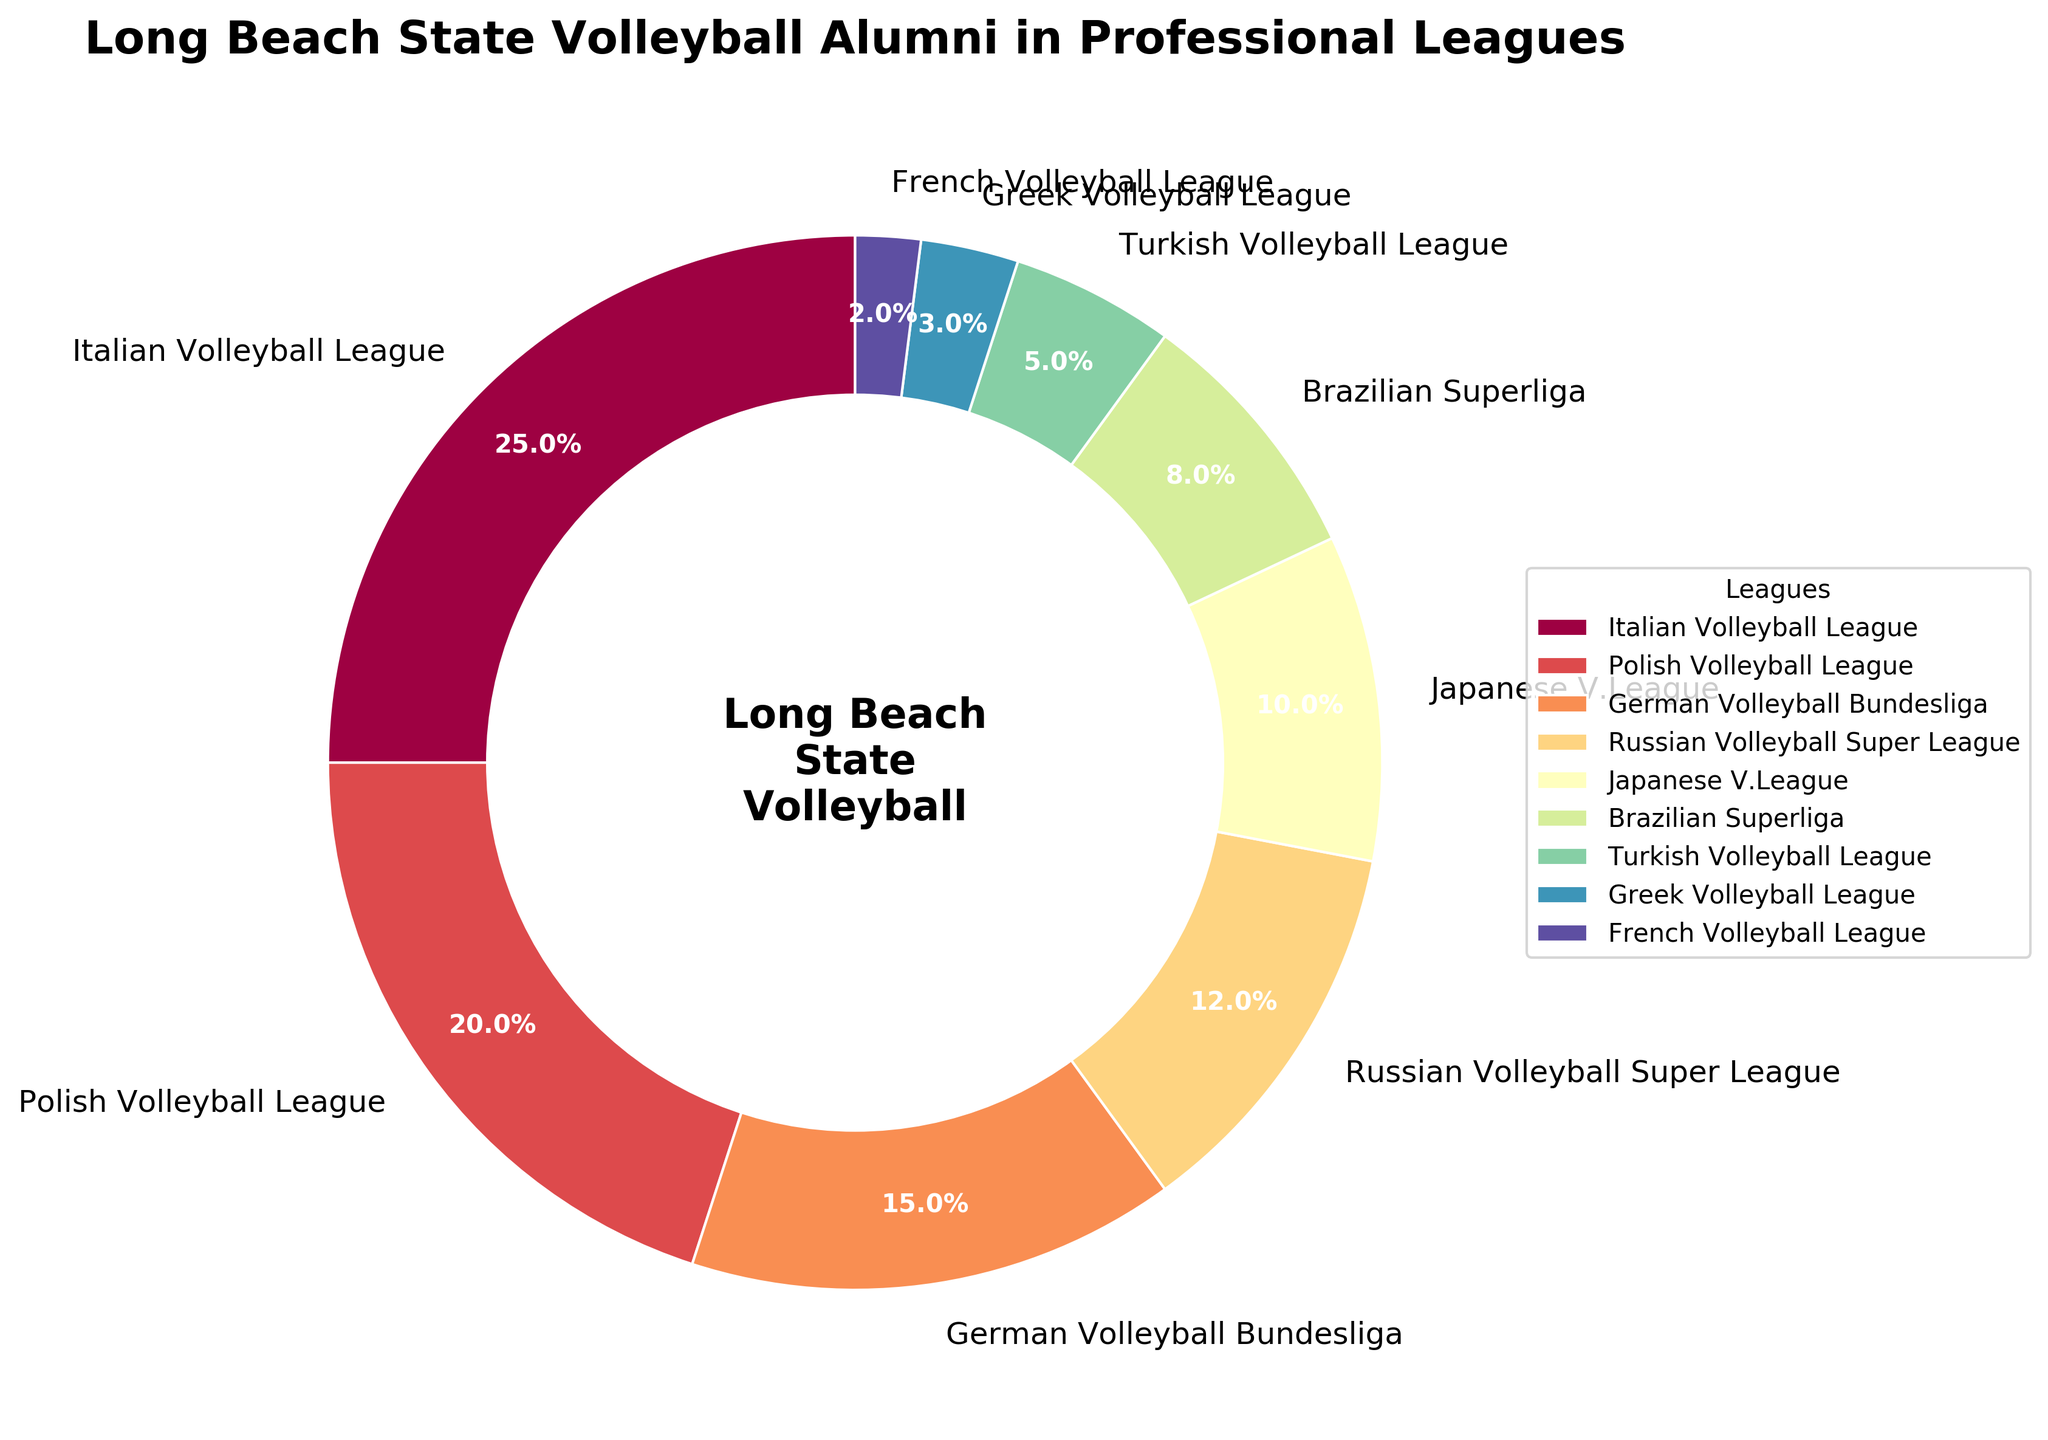What percentage of Long Beach State volleyball alumni are playing in the Italian Volleyball League? The pie chart shows that the Italian Volleyball League slice is labeled with the percentage 25%.
Answer: 25% Which league has the smallest percentage of Long Beach State volleyball alumni players? By visually examining the pie chart, the slice labeled 'French Volleyball League' appears to be the smallest, specifically labeled with 2%.
Answer: French Volleyball League What is the combined percentage of alumni playing in the Italian and Polish Volleyball Leagues? From the pie chart, we know that the Italian Volleyball League has 25% and the Polish Volleyball League has 20%. Adding these gives us 25% + 20% = 45%.
Answer: 45% How much larger is the percentage of alumni in the Italian Volleyball League compared to the Brazilian Superliga? The pie chart shows the Italian Volleyball League at 25% and the Brazilian Superliga at 8%. The difference is 25% - 8% = 17%.
Answer: 17% Among the German Volleyball Bundesliga and Russian Volleyball Super League, which one has more alumni players and by what percentage? From the pie chart, the German Volleyball Bundesliga is at 15% and the Russian Volleyball Super League is at 12%. The German league has more players by 15% - 12% = 3%.
Answer: German Volleyball Bundesliga by 3% What is the total percentage of alumni playing in leagues from Europe (Italian, Polish, German, Russian, Turkish, Greek, and French)? Adding up the percentages from the pie chart for the leagues in Europe: 25% (Italian) + 20% (Polish) + 15% (German) + 12% (Russian) + 5% (Turkish) + 3% (Greek) + 2% (French) = 82%.
Answer: 82% How does the percentage of alumni in the Japanese V.League compare to the Turkish Volleyball League? The pie chart indicates that the Japanese V.League has 10% and the Turkish Volleyball League has 5%. Therefore, the Japanese V.League has exactly double the percentage of alumni as the Turkish league.
Answer: Japanese V.League has double If a new league acquires 2% of the alumni, reducing the largest league's percentage by the same amount, what will the new percentage for the largest league be? The Italian Volleyball League is the largest at 25%. If 2% is transferred to a new league, its new percentage would be 25% - 2% = 23%.
Answer: 23% What is the average percentage of alumni across the Turkish, Greek, and French Volleyball Leagues? From the pie chart: Turkish = 5%, Greek = 3%, French = 2%. The total is 5% + 3% + 2% = 10%, and there are 3 leagues, so the average is 10% / 3 = 3.33%.
Answer: 3.33% 